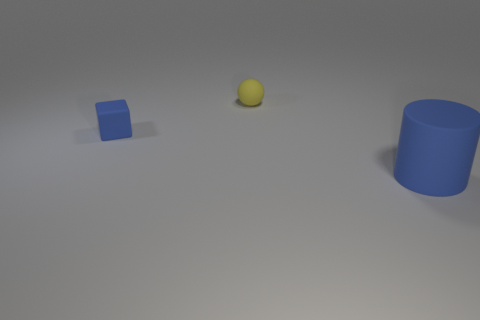Add 1 purple rubber objects. How many objects exist? 4 Subtract all cubes. How many objects are left? 2 Subtract all small yellow metal cylinders. Subtract all tiny yellow spheres. How many objects are left? 2 Add 2 small yellow objects. How many small yellow objects are left? 3 Add 1 yellow rubber balls. How many yellow rubber balls exist? 2 Subtract 0 cyan blocks. How many objects are left? 3 